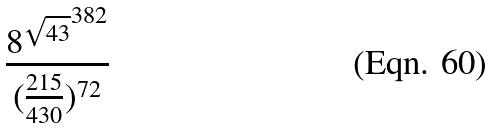Convert formula to latex. <formula><loc_0><loc_0><loc_500><loc_500>\frac { { 8 ^ { \sqrt { 4 3 } } } ^ { 3 8 2 } } { ( \frac { 2 1 5 } { 4 3 0 } ) ^ { 7 2 } }</formula> 